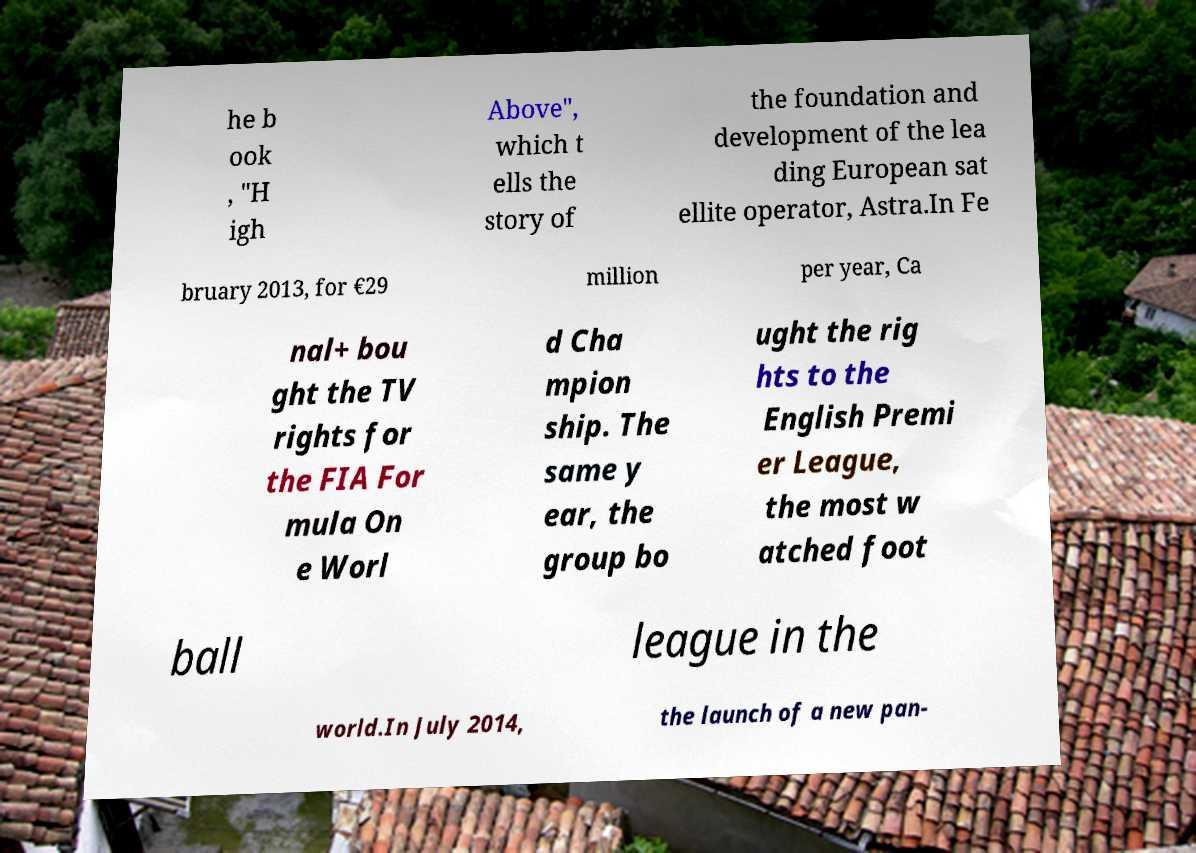There's text embedded in this image that I need extracted. Can you transcribe it verbatim? he b ook , "H igh Above", which t ells the story of the foundation and development of the lea ding European sat ellite operator, Astra.In Fe bruary 2013, for €29 million per year, Ca nal+ bou ght the TV rights for the FIA For mula On e Worl d Cha mpion ship. The same y ear, the group bo ught the rig hts to the English Premi er League, the most w atched foot ball league in the world.In July 2014, the launch of a new pan- 